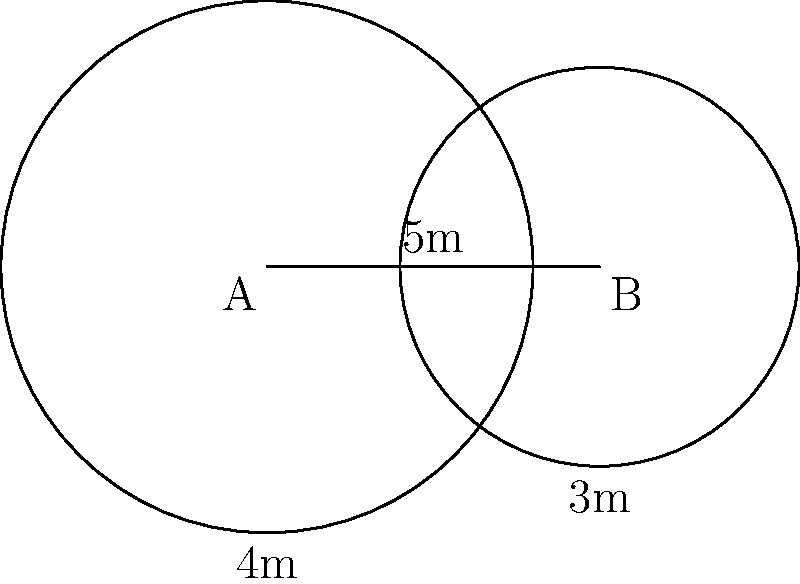As a rugby coach, you've set up two circular training zones on the field. Zone A has a radius of 4 meters, and Zone B has a radius of 3 meters. The centers of these zones are 5 meters apart. Calculate the area of overlap between these two training zones, rounding your answer to the nearest square meter. To solve this problem, we'll use the formula for the area of overlap between two circles. Let's approach this step-by-step:

1) First, we need to calculate the distance $d$ from the center of each circle to the line of intersection. We can do this using the formula:

   $$d = \frac{r_1^2 - r_2^2 + a^2}{2a}$$

   Where $r_1 = 4$ (radius of circle A), $r_2 = 3$ (radius of circle B), and $a = 5$ (distance between centers).

2) Plugging in the values:

   $$d = \frac{4^2 - 3^2 + 5^2}{2(5)} = \frac{16 - 9 + 25}{10} = \frac{32}{10} = 3.2$$

3) Now we can calculate the central angle $\theta$ for each circle using the arccos function:

   For circle A: $\theta_1 = 2 \arccos(\frac{d}{r_1}) = 2 \arccos(\frac{3.2}{4})$
   For circle B: $\theta_2 = 2 \arccos(\frac{5-3.2}{3}) = 2 \arccos(\frac{1.8}{3})$

4) Convert these angles to radians:

   $\theta_1 = 2.2143$ radians
   $\theta_2 = 2.7307$ radians

5) Now we can calculate the area of overlap using the formula:

   $$A = r_1^2 (\theta_1 - \sin\theta_1) + r_2^2 (\theta_2 - \sin\theta_2)$$

6) Plugging in the values:

   $$A = 4^2 (2.2143 - \sin(2.2143)) + 3^2 (2.7307 - \sin(2.7307))$$
   $$A = 16(2.2143 - 0.8128) + 9(2.7307 - 0.4048)$$
   $$A = 22.4240 + 20.9331 = 43.3571$$

7) Rounding to the nearest square meter:

   $A \approx 43$ square meters
Answer: 43 square meters 